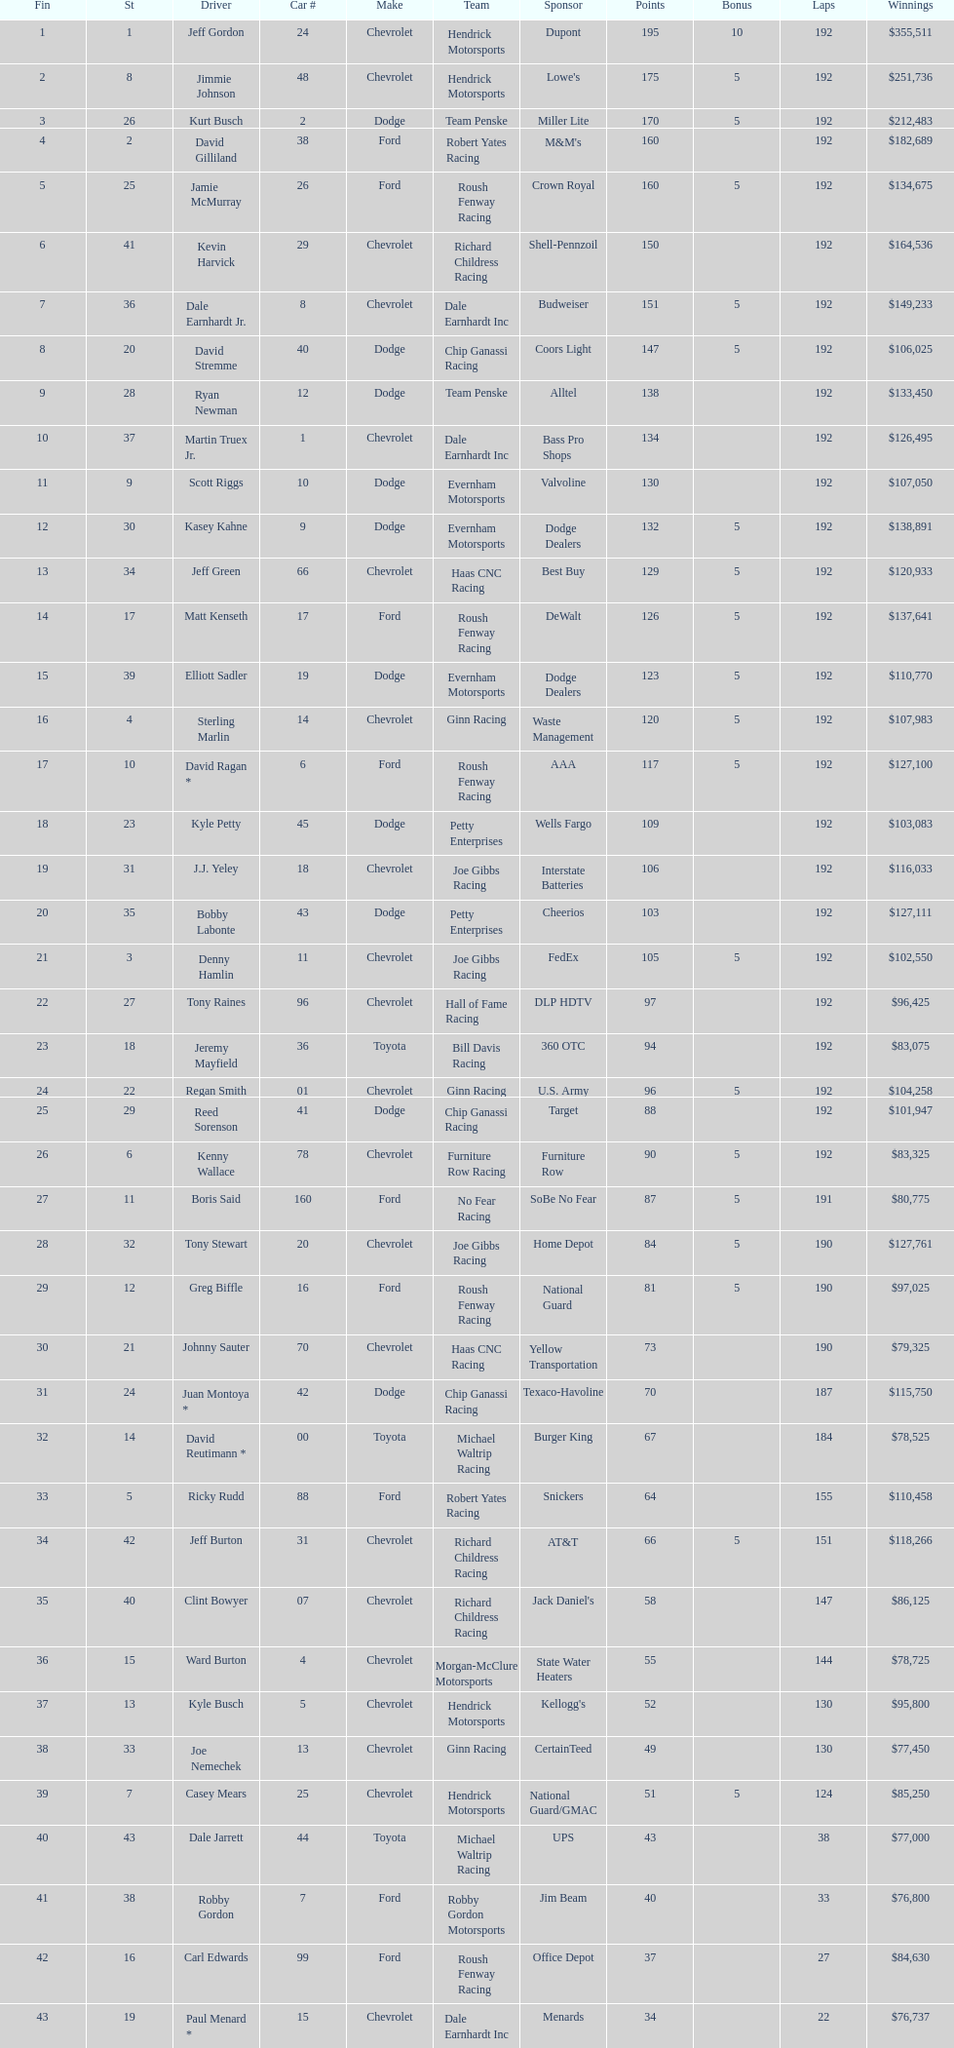How many drivers placed below tony stewart? 15. 